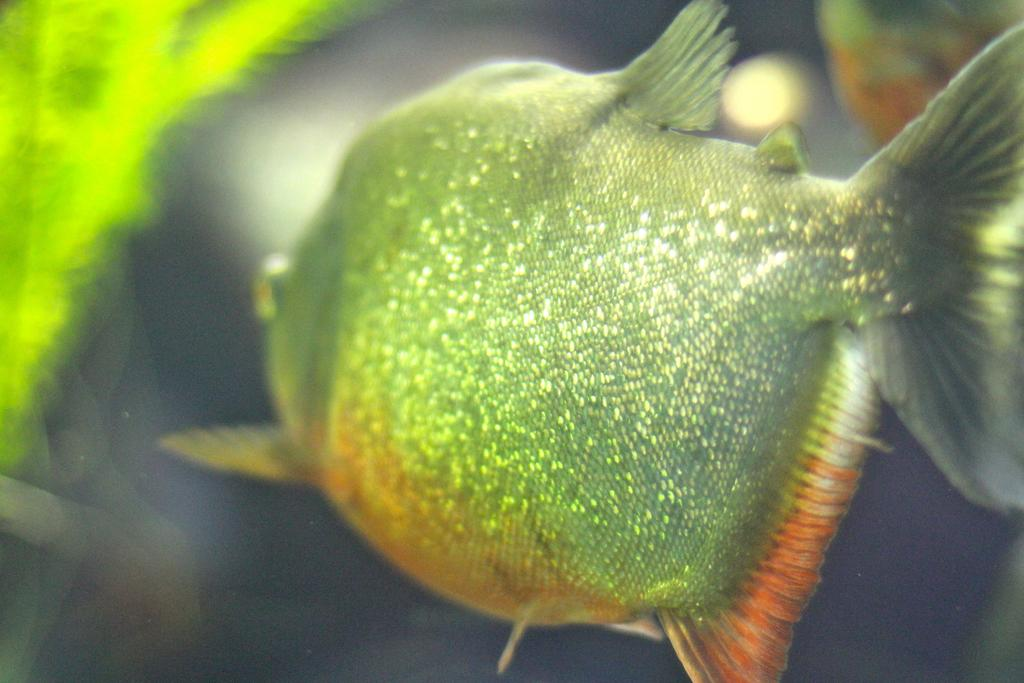What is the main subject in the center of the image? There is a fish in the center of the image. What color is the fish? The fish is green in color. What else can be seen around the fish in the image? There are other objects around the fish. How many mountains can be seen in the image? There are no mountains present in the image. What type of bag is being used to wash the fish in the image? There is no bag or washing activity depicted in the image; it features a green fish in the center with other objects around it. 